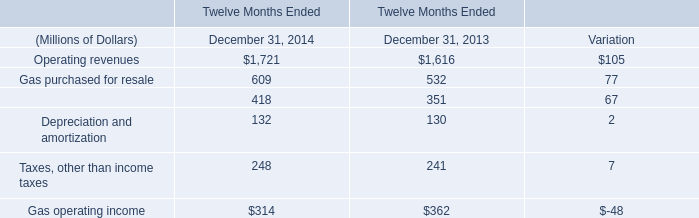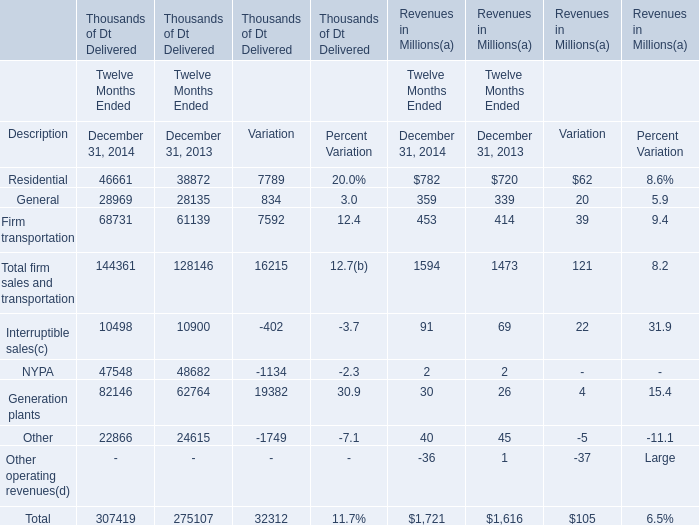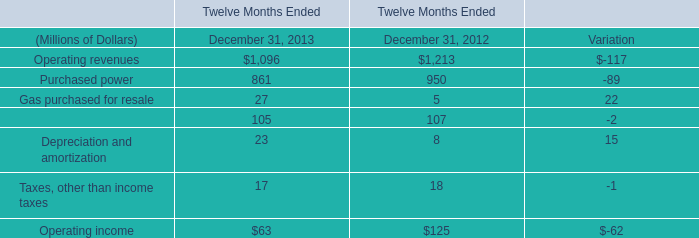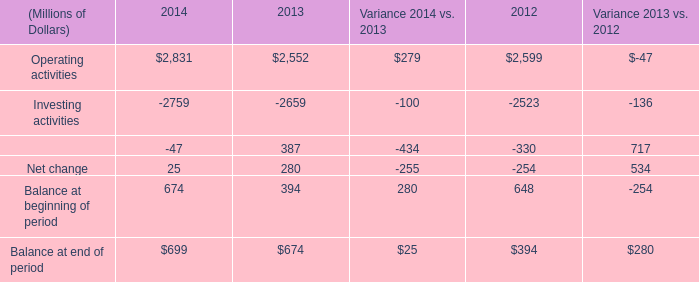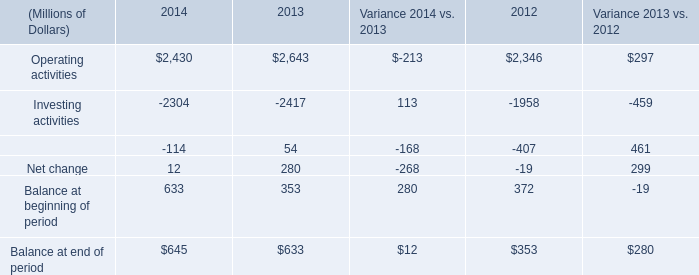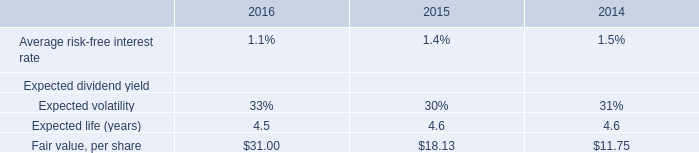Which year is General for Thousands of Dt Delivered the least? 
Answer: 2013. 